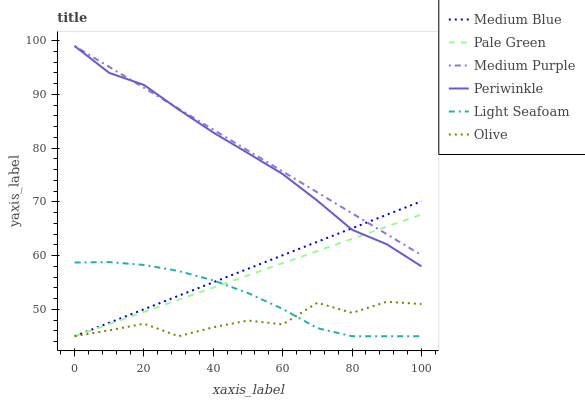Does Olive have the minimum area under the curve?
Answer yes or no. Yes. Does Medium Purple have the maximum area under the curve?
Answer yes or no. Yes. Does Pale Green have the minimum area under the curve?
Answer yes or no. No. Does Pale Green have the maximum area under the curve?
Answer yes or no. No. Is Medium Purple the smoothest?
Answer yes or no. Yes. Is Olive the roughest?
Answer yes or no. Yes. Is Pale Green the smoothest?
Answer yes or no. No. Is Pale Green the roughest?
Answer yes or no. No. Does Medium Blue have the lowest value?
Answer yes or no. Yes. Does Medium Purple have the lowest value?
Answer yes or no. No. Does Periwinkle have the highest value?
Answer yes or no. Yes. Does Pale Green have the highest value?
Answer yes or no. No. Is Olive less than Periwinkle?
Answer yes or no. Yes. Is Medium Purple greater than Light Seafoam?
Answer yes or no. Yes. Does Light Seafoam intersect Olive?
Answer yes or no. Yes. Is Light Seafoam less than Olive?
Answer yes or no. No. Is Light Seafoam greater than Olive?
Answer yes or no. No. Does Olive intersect Periwinkle?
Answer yes or no. No. 